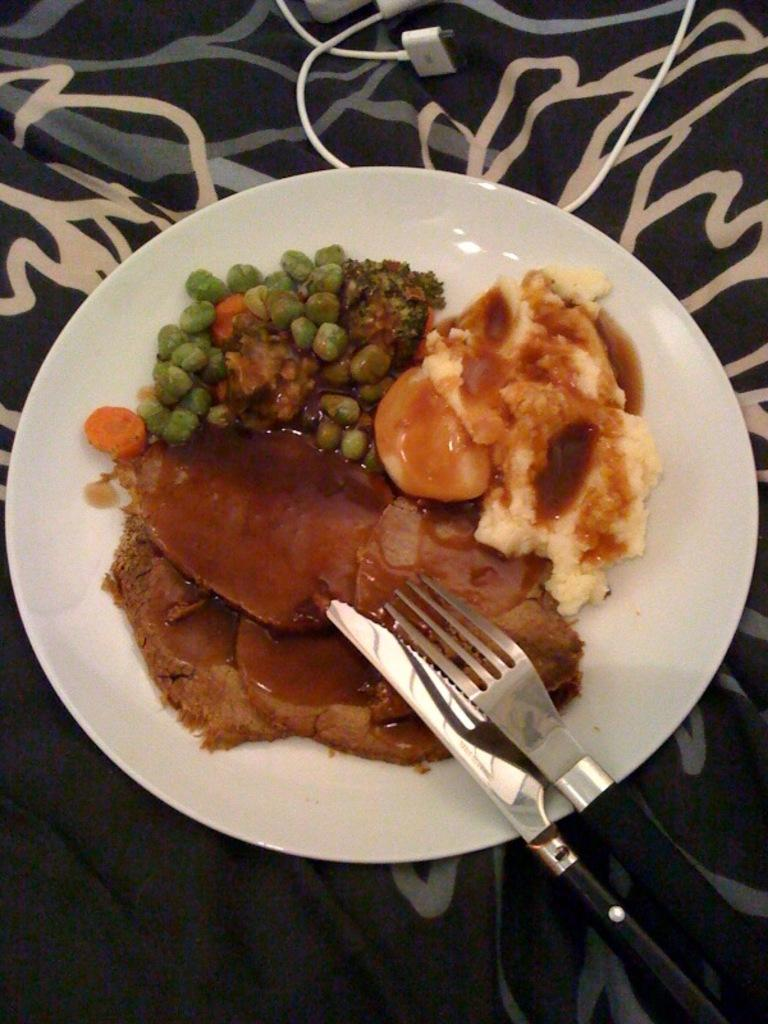What is on the plate that is visible in the image? There is a plate with food in the image. What utensils are present in the image? There is a fork and a knife in the image. What other object can be seen in the image besides the plate and utensils? There is a cable and an object that resembles a blanket in the image. What rule does the son break in the image? There is no son or rule-breaking behavior depicted in the image. 